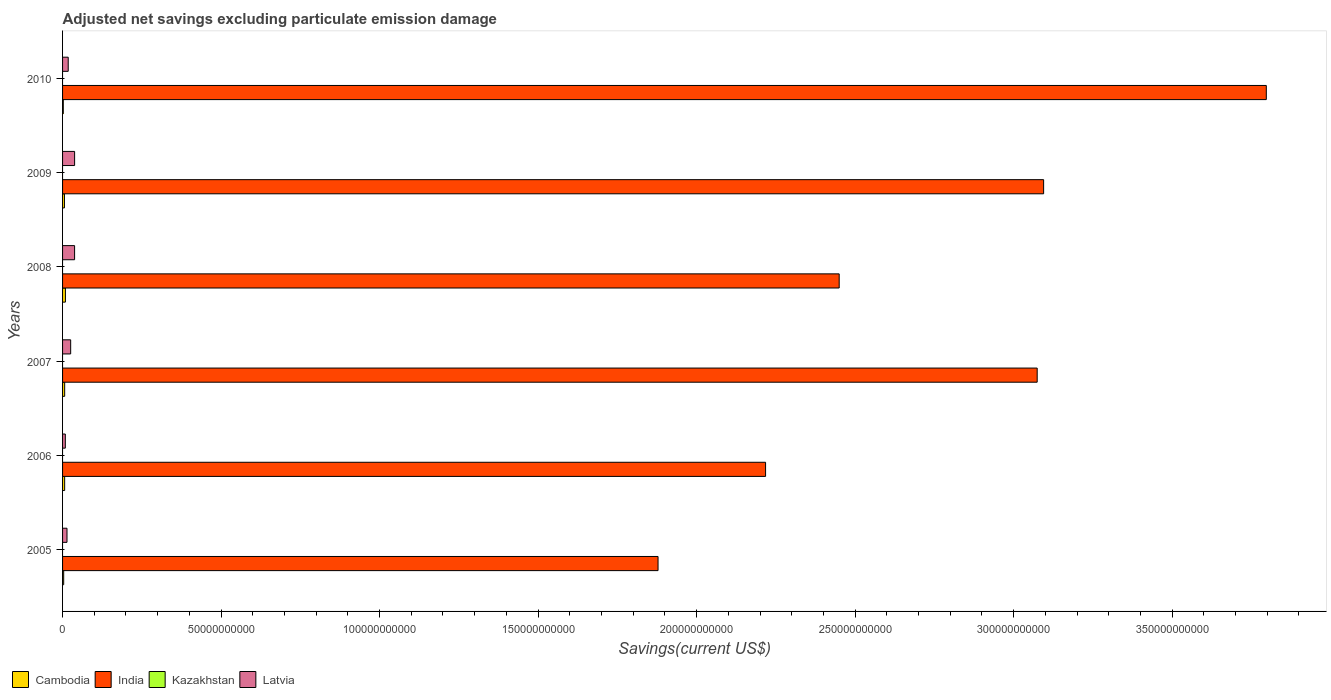How many different coloured bars are there?
Keep it short and to the point. 3. Are the number of bars per tick equal to the number of legend labels?
Keep it short and to the point. No. Are the number of bars on each tick of the Y-axis equal?
Offer a very short reply. Yes. How many bars are there on the 1st tick from the bottom?
Give a very brief answer. 3. What is the label of the 1st group of bars from the top?
Provide a succinct answer. 2010. What is the adjusted net savings in Cambodia in 2007?
Provide a succinct answer. 6.62e+08. Across all years, what is the maximum adjusted net savings in India?
Your answer should be very brief. 3.80e+11. Across all years, what is the minimum adjusted net savings in Cambodia?
Provide a short and direct response. 2.31e+08. In which year was the adjusted net savings in Latvia maximum?
Offer a very short reply. 2009. What is the total adjusted net savings in Cambodia in the graph?
Offer a very short reply. 3.40e+09. What is the difference between the adjusted net savings in Cambodia in 2008 and that in 2009?
Ensure brevity in your answer.  3.04e+08. What is the difference between the adjusted net savings in India in 2010 and the adjusted net savings in Latvia in 2008?
Ensure brevity in your answer.  3.76e+11. What is the average adjusted net savings in Kazakhstan per year?
Ensure brevity in your answer.  0. In the year 2006, what is the difference between the adjusted net savings in India and adjusted net savings in Cambodia?
Your answer should be compact. 2.21e+11. In how many years, is the adjusted net savings in India greater than 40000000000 US$?
Your answer should be compact. 6. What is the ratio of the adjusted net savings in India in 2005 to that in 2010?
Keep it short and to the point. 0.49. Is the difference between the adjusted net savings in India in 2008 and 2010 greater than the difference between the adjusted net savings in Cambodia in 2008 and 2010?
Your response must be concise. No. What is the difference between the highest and the second highest adjusted net savings in Cambodia?
Provide a short and direct response. 2.39e+08. What is the difference between the highest and the lowest adjusted net savings in Latvia?
Give a very brief answer. 2.93e+09. Is it the case that in every year, the sum of the adjusted net savings in Latvia and adjusted net savings in India is greater than the adjusted net savings in Kazakhstan?
Give a very brief answer. Yes. How many bars are there?
Offer a terse response. 18. How many years are there in the graph?
Ensure brevity in your answer.  6. Where does the legend appear in the graph?
Offer a terse response. Bottom left. What is the title of the graph?
Make the answer very short. Adjusted net savings excluding particulate emission damage. Does "Peru" appear as one of the legend labels in the graph?
Offer a terse response. No. What is the label or title of the X-axis?
Your answer should be very brief. Savings(current US$). What is the label or title of the Y-axis?
Your answer should be compact. Years. What is the Savings(current US$) of Cambodia in 2005?
Your answer should be very brief. 3.53e+08. What is the Savings(current US$) in India in 2005?
Your answer should be very brief. 1.88e+11. What is the Savings(current US$) in Kazakhstan in 2005?
Offer a terse response. 0. What is the Savings(current US$) in Latvia in 2005?
Keep it short and to the point. 1.40e+09. What is the Savings(current US$) of Cambodia in 2006?
Offer a very short reply. 6.58e+08. What is the Savings(current US$) of India in 2006?
Your response must be concise. 2.22e+11. What is the Savings(current US$) in Kazakhstan in 2006?
Provide a succinct answer. 0. What is the Savings(current US$) in Latvia in 2006?
Your answer should be compact. 8.71e+08. What is the Savings(current US$) of Cambodia in 2007?
Your answer should be compact. 6.62e+08. What is the Savings(current US$) in India in 2007?
Keep it short and to the point. 3.07e+11. What is the Savings(current US$) of Latvia in 2007?
Keep it short and to the point. 2.56e+09. What is the Savings(current US$) in Cambodia in 2008?
Your answer should be very brief. 9.01e+08. What is the Savings(current US$) in India in 2008?
Offer a terse response. 2.45e+11. What is the Savings(current US$) in Latvia in 2008?
Provide a short and direct response. 3.79e+09. What is the Savings(current US$) in Cambodia in 2009?
Your response must be concise. 5.97e+08. What is the Savings(current US$) in India in 2009?
Provide a short and direct response. 3.09e+11. What is the Savings(current US$) of Latvia in 2009?
Your answer should be very brief. 3.80e+09. What is the Savings(current US$) in Cambodia in 2010?
Provide a succinct answer. 2.31e+08. What is the Savings(current US$) of India in 2010?
Ensure brevity in your answer.  3.80e+11. What is the Savings(current US$) of Kazakhstan in 2010?
Your answer should be compact. 0. What is the Savings(current US$) in Latvia in 2010?
Your answer should be compact. 1.78e+09. Across all years, what is the maximum Savings(current US$) in Cambodia?
Offer a terse response. 9.01e+08. Across all years, what is the maximum Savings(current US$) in India?
Your response must be concise. 3.80e+11. Across all years, what is the maximum Savings(current US$) of Latvia?
Keep it short and to the point. 3.80e+09. Across all years, what is the minimum Savings(current US$) in Cambodia?
Offer a very short reply. 2.31e+08. Across all years, what is the minimum Savings(current US$) of India?
Keep it short and to the point. 1.88e+11. Across all years, what is the minimum Savings(current US$) in Latvia?
Provide a short and direct response. 8.71e+08. What is the total Savings(current US$) in Cambodia in the graph?
Keep it short and to the point. 3.40e+09. What is the total Savings(current US$) in India in the graph?
Your response must be concise. 1.65e+12. What is the total Savings(current US$) in Kazakhstan in the graph?
Your answer should be very brief. 0. What is the total Savings(current US$) in Latvia in the graph?
Provide a succinct answer. 1.42e+1. What is the difference between the Savings(current US$) in Cambodia in 2005 and that in 2006?
Your answer should be compact. -3.05e+08. What is the difference between the Savings(current US$) of India in 2005 and that in 2006?
Provide a short and direct response. -3.39e+1. What is the difference between the Savings(current US$) of Latvia in 2005 and that in 2006?
Your answer should be compact. 5.25e+08. What is the difference between the Savings(current US$) of Cambodia in 2005 and that in 2007?
Make the answer very short. -3.09e+08. What is the difference between the Savings(current US$) in India in 2005 and that in 2007?
Give a very brief answer. -1.20e+11. What is the difference between the Savings(current US$) of Latvia in 2005 and that in 2007?
Provide a short and direct response. -1.16e+09. What is the difference between the Savings(current US$) in Cambodia in 2005 and that in 2008?
Give a very brief answer. -5.48e+08. What is the difference between the Savings(current US$) in India in 2005 and that in 2008?
Ensure brevity in your answer.  -5.71e+1. What is the difference between the Savings(current US$) of Latvia in 2005 and that in 2008?
Offer a terse response. -2.40e+09. What is the difference between the Savings(current US$) of Cambodia in 2005 and that in 2009?
Keep it short and to the point. -2.44e+08. What is the difference between the Savings(current US$) of India in 2005 and that in 2009?
Offer a terse response. -1.22e+11. What is the difference between the Savings(current US$) of Latvia in 2005 and that in 2009?
Make the answer very short. -2.40e+09. What is the difference between the Savings(current US$) of Cambodia in 2005 and that in 2010?
Your answer should be very brief. 1.22e+08. What is the difference between the Savings(current US$) in India in 2005 and that in 2010?
Keep it short and to the point. -1.92e+11. What is the difference between the Savings(current US$) in Latvia in 2005 and that in 2010?
Offer a terse response. -3.87e+08. What is the difference between the Savings(current US$) in Cambodia in 2006 and that in 2007?
Keep it short and to the point. -3.74e+06. What is the difference between the Savings(current US$) of India in 2006 and that in 2007?
Give a very brief answer. -8.57e+1. What is the difference between the Savings(current US$) of Latvia in 2006 and that in 2007?
Provide a short and direct response. -1.68e+09. What is the difference between the Savings(current US$) of Cambodia in 2006 and that in 2008?
Your answer should be compact. -2.43e+08. What is the difference between the Savings(current US$) in India in 2006 and that in 2008?
Provide a short and direct response. -2.32e+1. What is the difference between the Savings(current US$) in Latvia in 2006 and that in 2008?
Offer a terse response. -2.92e+09. What is the difference between the Savings(current US$) of Cambodia in 2006 and that in 2009?
Give a very brief answer. 6.14e+07. What is the difference between the Savings(current US$) in India in 2006 and that in 2009?
Provide a succinct answer. -8.77e+1. What is the difference between the Savings(current US$) of Latvia in 2006 and that in 2009?
Make the answer very short. -2.93e+09. What is the difference between the Savings(current US$) in Cambodia in 2006 and that in 2010?
Provide a succinct answer. 4.27e+08. What is the difference between the Savings(current US$) in India in 2006 and that in 2010?
Keep it short and to the point. -1.58e+11. What is the difference between the Savings(current US$) of Latvia in 2006 and that in 2010?
Provide a succinct answer. -9.13e+08. What is the difference between the Savings(current US$) in Cambodia in 2007 and that in 2008?
Offer a terse response. -2.39e+08. What is the difference between the Savings(current US$) of India in 2007 and that in 2008?
Your answer should be very brief. 6.25e+1. What is the difference between the Savings(current US$) in Latvia in 2007 and that in 2008?
Provide a succinct answer. -1.24e+09. What is the difference between the Savings(current US$) in Cambodia in 2007 and that in 2009?
Your answer should be very brief. 6.52e+07. What is the difference between the Savings(current US$) in India in 2007 and that in 2009?
Give a very brief answer. -2.03e+09. What is the difference between the Savings(current US$) in Latvia in 2007 and that in 2009?
Offer a terse response. -1.24e+09. What is the difference between the Savings(current US$) in Cambodia in 2007 and that in 2010?
Keep it short and to the point. 4.31e+08. What is the difference between the Savings(current US$) in India in 2007 and that in 2010?
Ensure brevity in your answer.  -7.23e+1. What is the difference between the Savings(current US$) in Latvia in 2007 and that in 2010?
Your answer should be very brief. 7.72e+08. What is the difference between the Savings(current US$) in Cambodia in 2008 and that in 2009?
Offer a terse response. 3.04e+08. What is the difference between the Savings(current US$) of India in 2008 and that in 2009?
Provide a succinct answer. -6.45e+1. What is the difference between the Savings(current US$) in Latvia in 2008 and that in 2009?
Your answer should be compact. -3.63e+06. What is the difference between the Savings(current US$) in Cambodia in 2008 and that in 2010?
Keep it short and to the point. 6.70e+08. What is the difference between the Savings(current US$) of India in 2008 and that in 2010?
Provide a succinct answer. -1.35e+11. What is the difference between the Savings(current US$) of Latvia in 2008 and that in 2010?
Make the answer very short. 2.01e+09. What is the difference between the Savings(current US$) of Cambodia in 2009 and that in 2010?
Your answer should be compact. 3.66e+08. What is the difference between the Savings(current US$) in India in 2009 and that in 2010?
Your answer should be very brief. -7.02e+1. What is the difference between the Savings(current US$) of Latvia in 2009 and that in 2010?
Make the answer very short. 2.01e+09. What is the difference between the Savings(current US$) in Cambodia in 2005 and the Savings(current US$) in India in 2006?
Your answer should be very brief. -2.21e+11. What is the difference between the Savings(current US$) in Cambodia in 2005 and the Savings(current US$) in Latvia in 2006?
Provide a short and direct response. -5.18e+08. What is the difference between the Savings(current US$) of India in 2005 and the Savings(current US$) of Latvia in 2006?
Your response must be concise. 1.87e+11. What is the difference between the Savings(current US$) of Cambodia in 2005 and the Savings(current US$) of India in 2007?
Your response must be concise. -3.07e+11. What is the difference between the Savings(current US$) of Cambodia in 2005 and the Savings(current US$) of Latvia in 2007?
Provide a succinct answer. -2.20e+09. What is the difference between the Savings(current US$) of India in 2005 and the Savings(current US$) of Latvia in 2007?
Give a very brief answer. 1.85e+11. What is the difference between the Savings(current US$) in Cambodia in 2005 and the Savings(current US$) in India in 2008?
Your answer should be compact. -2.45e+11. What is the difference between the Savings(current US$) in Cambodia in 2005 and the Savings(current US$) in Latvia in 2008?
Make the answer very short. -3.44e+09. What is the difference between the Savings(current US$) of India in 2005 and the Savings(current US$) of Latvia in 2008?
Make the answer very short. 1.84e+11. What is the difference between the Savings(current US$) of Cambodia in 2005 and the Savings(current US$) of India in 2009?
Offer a terse response. -3.09e+11. What is the difference between the Savings(current US$) of Cambodia in 2005 and the Savings(current US$) of Latvia in 2009?
Make the answer very short. -3.44e+09. What is the difference between the Savings(current US$) of India in 2005 and the Savings(current US$) of Latvia in 2009?
Make the answer very short. 1.84e+11. What is the difference between the Savings(current US$) of Cambodia in 2005 and the Savings(current US$) of India in 2010?
Offer a very short reply. -3.79e+11. What is the difference between the Savings(current US$) in Cambodia in 2005 and the Savings(current US$) in Latvia in 2010?
Make the answer very short. -1.43e+09. What is the difference between the Savings(current US$) of India in 2005 and the Savings(current US$) of Latvia in 2010?
Provide a succinct answer. 1.86e+11. What is the difference between the Savings(current US$) of Cambodia in 2006 and the Savings(current US$) of India in 2007?
Ensure brevity in your answer.  -3.07e+11. What is the difference between the Savings(current US$) in Cambodia in 2006 and the Savings(current US$) in Latvia in 2007?
Keep it short and to the point. -1.90e+09. What is the difference between the Savings(current US$) in India in 2006 and the Savings(current US$) in Latvia in 2007?
Offer a terse response. 2.19e+11. What is the difference between the Savings(current US$) of Cambodia in 2006 and the Savings(current US$) of India in 2008?
Keep it short and to the point. -2.44e+11. What is the difference between the Savings(current US$) of Cambodia in 2006 and the Savings(current US$) of Latvia in 2008?
Offer a terse response. -3.14e+09. What is the difference between the Savings(current US$) of India in 2006 and the Savings(current US$) of Latvia in 2008?
Make the answer very short. 2.18e+11. What is the difference between the Savings(current US$) of Cambodia in 2006 and the Savings(current US$) of India in 2009?
Give a very brief answer. -3.09e+11. What is the difference between the Savings(current US$) of Cambodia in 2006 and the Savings(current US$) of Latvia in 2009?
Provide a succinct answer. -3.14e+09. What is the difference between the Savings(current US$) of India in 2006 and the Savings(current US$) of Latvia in 2009?
Keep it short and to the point. 2.18e+11. What is the difference between the Savings(current US$) in Cambodia in 2006 and the Savings(current US$) in India in 2010?
Keep it short and to the point. -3.79e+11. What is the difference between the Savings(current US$) in Cambodia in 2006 and the Savings(current US$) in Latvia in 2010?
Keep it short and to the point. -1.13e+09. What is the difference between the Savings(current US$) in India in 2006 and the Savings(current US$) in Latvia in 2010?
Give a very brief answer. 2.20e+11. What is the difference between the Savings(current US$) in Cambodia in 2007 and the Savings(current US$) in India in 2008?
Your answer should be compact. -2.44e+11. What is the difference between the Savings(current US$) in Cambodia in 2007 and the Savings(current US$) in Latvia in 2008?
Your answer should be very brief. -3.13e+09. What is the difference between the Savings(current US$) of India in 2007 and the Savings(current US$) of Latvia in 2008?
Ensure brevity in your answer.  3.04e+11. What is the difference between the Savings(current US$) in Cambodia in 2007 and the Savings(current US$) in India in 2009?
Provide a succinct answer. -3.09e+11. What is the difference between the Savings(current US$) of Cambodia in 2007 and the Savings(current US$) of Latvia in 2009?
Provide a short and direct response. -3.14e+09. What is the difference between the Savings(current US$) of India in 2007 and the Savings(current US$) of Latvia in 2009?
Make the answer very short. 3.04e+11. What is the difference between the Savings(current US$) of Cambodia in 2007 and the Savings(current US$) of India in 2010?
Your answer should be very brief. -3.79e+11. What is the difference between the Savings(current US$) in Cambodia in 2007 and the Savings(current US$) in Latvia in 2010?
Provide a succinct answer. -1.12e+09. What is the difference between the Savings(current US$) of India in 2007 and the Savings(current US$) of Latvia in 2010?
Offer a very short reply. 3.06e+11. What is the difference between the Savings(current US$) of Cambodia in 2008 and the Savings(current US$) of India in 2009?
Make the answer very short. -3.09e+11. What is the difference between the Savings(current US$) in Cambodia in 2008 and the Savings(current US$) in Latvia in 2009?
Provide a short and direct response. -2.90e+09. What is the difference between the Savings(current US$) in India in 2008 and the Savings(current US$) in Latvia in 2009?
Keep it short and to the point. 2.41e+11. What is the difference between the Savings(current US$) of Cambodia in 2008 and the Savings(current US$) of India in 2010?
Keep it short and to the point. -3.79e+11. What is the difference between the Savings(current US$) of Cambodia in 2008 and the Savings(current US$) of Latvia in 2010?
Provide a short and direct response. -8.83e+08. What is the difference between the Savings(current US$) of India in 2008 and the Savings(current US$) of Latvia in 2010?
Ensure brevity in your answer.  2.43e+11. What is the difference between the Savings(current US$) in Cambodia in 2009 and the Savings(current US$) in India in 2010?
Provide a succinct answer. -3.79e+11. What is the difference between the Savings(current US$) in Cambodia in 2009 and the Savings(current US$) in Latvia in 2010?
Ensure brevity in your answer.  -1.19e+09. What is the difference between the Savings(current US$) of India in 2009 and the Savings(current US$) of Latvia in 2010?
Keep it short and to the point. 3.08e+11. What is the average Savings(current US$) in Cambodia per year?
Your answer should be very brief. 5.67e+08. What is the average Savings(current US$) in India per year?
Your answer should be compact. 2.75e+11. What is the average Savings(current US$) in Kazakhstan per year?
Your answer should be compact. 0. What is the average Savings(current US$) in Latvia per year?
Provide a succinct answer. 2.37e+09. In the year 2005, what is the difference between the Savings(current US$) in Cambodia and Savings(current US$) in India?
Make the answer very short. -1.87e+11. In the year 2005, what is the difference between the Savings(current US$) of Cambodia and Savings(current US$) of Latvia?
Ensure brevity in your answer.  -1.04e+09. In the year 2005, what is the difference between the Savings(current US$) of India and Savings(current US$) of Latvia?
Your response must be concise. 1.86e+11. In the year 2006, what is the difference between the Savings(current US$) of Cambodia and Savings(current US$) of India?
Your answer should be compact. -2.21e+11. In the year 2006, what is the difference between the Savings(current US$) in Cambodia and Savings(current US$) in Latvia?
Your response must be concise. -2.13e+08. In the year 2006, what is the difference between the Savings(current US$) in India and Savings(current US$) in Latvia?
Provide a succinct answer. 2.21e+11. In the year 2007, what is the difference between the Savings(current US$) in Cambodia and Savings(current US$) in India?
Provide a short and direct response. -3.07e+11. In the year 2007, what is the difference between the Savings(current US$) of Cambodia and Savings(current US$) of Latvia?
Your answer should be very brief. -1.89e+09. In the year 2007, what is the difference between the Savings(current US$) in India and Savings(current US$) in Latvia?
Your answer should be compact. 3.05e+11. In the year 2008, what is the difference between the Savings(current US$) in Cambodia and Savings(current US$) in India?
Ensure brevity in your answer.  -2.44e+11. In the year 2008, what is the difference between the Savings(current US$) of Cambodia and Savings(current US$) of Latvia?
Your answer should be compact. -2.89e+09. In the year 2008, what is the difference between the Savings(current US$) of India and Savings(current US$) of Latvia?
Provide a short and direct response. 2.41e+11. In the year 2009, what is the difference between the Savings(current US$) in Cambodia and Savings(current US$) in India?
Provide a succinct answer. -3.09e+11. In the year 2009, what is the difference between the Savings(current US$) in Cambodia and Savings(current US$) in Latvia?
Offer a terse response. -3.20e+09. In the year 2009, what is the difference between the Savings(current US$) of India and Savings(current US$) of Latvia?
Make the answer very short. 3.06e+11. In the year 2010, what is the difference between the Savings(current US$) in Cambodia and Savings(current US$) in India?
Ensure brevity in your answer.  -3.79e+11. In the year 2010, what is the difference between the Savings(current US$) in Cambodia and Savings(current US$) in Latvia?
Provide a succinct answer. -1.55e+09. In the year 2010, what is the difference between the Savings(current US$) of India and Savings(current US$) of Latvia?
Your response must be concise. 3.78e+11. What is the ratio of the Savings(current US$) of Cambodia in 2005 to that in 2006?
Offer a terse response. 0.54. What is the ratio of the Savings(current US$) of India in 2005 to that in 2006?
Offer a terse response. 0.85. What is the ratio of the Savings(current US$) in Latvia in 2005 to that in 2006?
Offer a terse response. 1.6. What is the ratio of the Savings(current US$) in Cambodia in 2005 to that in 2007?
Keep it short and to the point. 0.53. What is the ratio of the Savings(current US$) in India in 2005 to that in 2007?
Provide a short and direct response. 0.61. What is the ratio of the Savings(current US$) in Latvia in 2005 to that in 2007?
Make the answer very short. 0.55. What is the ratio of the Savings(current US$) of Cambodia in 2005 to that in 2008?
Provide a short and direct response. 0.39. What is the ratio of the Savings(current US$) of India in 2005 to that in 2008?
Provide a short and direct response. 0.77. What is the ratio of the Savings(current US$) of Latvia in 2005 to that in 2008?
Give a very brief answer. 0.37. What is the ratio of the Savings(current US$) in Cambodia in 2005 to that in 2009?
Keep it short and to the point. 0.59. What is the ratio of the Savings(current US$) of India in 2005 to that in 2009?
Offer a very short reply. 0.61. What is the ratio of the Savings(current US$) in Latvia in 2005 to that in 2009?
Your answer should be very brief. 0.37. What is the ratio of the Savings(current US$) of Cambodia in 2005 to that in 2010?
Provide a short and direct response. 1.53. What is the ratio of the Savings(current US$) in India in 2005 to that in 2010?
Offer a terse response. 0.49. What is the ratio of the Savings(current US$) in Latvia in 2005 to that in 2010?
Your response must be concise. 0.78. What is the ratio of the Savings(current US$) of Cambodia in 2006 to that in 2007?
Offer a very short reply. 0.99. What is the ratio of the Savings(current US$) in India in 2006 to that in 2007?
Give a very brief answer. 0.72. What is the ratio of the Savings(current US$) of Latvia in 2006 to that in 2007?
Offer a very short reply. 0.34. What is the ratio of the Savings(current US$) of Cambodia in 2006 to that in 2008?
Provide a succinct answer. 0.73. What is the ratio of the Savings(current US$) of India in 2006 to that in 2008?
Make the answer very short. 0.91. What is the ratio of the Savings(current US$) in Latvia in 2006 to that in 2008?
Provide a short and direct response. 0.23. What is the ratio of the Savings(current US$) of Cambodia in 2006 to that in 2009?
Provide a succinct answer. 1.1. What is the ratio of the Savings(current US$) in India in 2006 to that in 2009?
Keep it short and to the point. 0.72. What is the ratio of the Savings(current US$) of Latvia in 2006 to that in 2009?
Make the answer very short. 0.23. What is the ratio of the Savings(current US$) in Cambodia in 2006 to that in 2010?
Ensure brevity in your answer.  2.85. What is the ratio of the Savings(current US$) in India in 2006 to that in 2010?
Your answer should be very brief. 0.58. What is the ratio of the Savings(current US$) in Latvia in 2006 to that in 2010?
Ensure brevity in your answer.  0.49. What is the ratio of the Savings(current US$) in Cambodia in 2007 to that in 2008?
Ensure brevity in your answer.  0.73. What is the ratio of the Savings(current US$) of India in 2007 to that in 2008?
Your answer should be compact. 1.25. What is the ratio of the Savings(current US$) of Latvia in 2007 to that in 2008?
Provide a short and direct response. 0.67. What is the ratio of the Savings(current US$) of Cambodia in 2007 to that in 2009?
Your response must be concise. 1.11. What is the ratio of the Savings(current US$) of Latvia in 2007 to that in 2009?
Offer a very short reply. 0.67. What is the ratio of the Savings(current US$) of Cambodia in 2007 to that in 2010?
Offer a terse response. 2.86. What is the ratio of the Savings(current US$) of India in 2007 to that in 2010?
Your answer should be compact. 0.81. What is the ratio of the Savings(current US$) of Latvia in 2007 to that in 2010?
Your answer should be very brief. 1.43. What is the ratio of the Savings(current US$) in Cambodia in 2008 to that in 2009?
Offer a very short reply. 1.51. What is the ratio of the Savings(current US$) in India in 2008 to that in 2009?
Make the answer very short. 0.79. What is the ratio of the Savings(current US$) of Latvia in 2008 to that in 2009?
Keep it short and to the point. 1. What is the ratio of the Savings(current US$) of Cambodia in 2008 to that in 2010?
Give a very brief answer. 3.9. What is the ratio of the Savings(current US$) in India in 2008 to that in 2010?
Offer a very short reply. 0.65. What is the ratio of the Savings(current US$) in Latvia in 2008 to that in 2010?
Offer a very short reply. 2.13. What is the ratio of the Savings(current US$) in Cambodia in 2009 to that in 2010?
Provide a succinct answer. 2.58. What is the ratio of the Savings(current US$) of India in 2009 to that in 2010?
Provide a short and direct response. 0.81. What is the ratio of the Savings(current US$) in Latvia in 2009 to that in 2010?
Your answer should be very brief. 2.13. What is the difference between the highest and the second highest Savings(current US$) of Cambodia?
Ensure brevity in your answer.  2.39e+08. What is the difference between the highest and the second highest Savings(current US$) of India?
Make the answer very short. 7.02e+1. What is the difference between the highest and the second highest Savings(current US$) in Latvia?
Provide a succinct answer. 3.63e+06. What is the difference between the highest and the lowest Savings(current US$) of Cambodia?
Make the answer very short. 6.70e+08. What is the difference between the highest and the lowest Savings(current US$) of India?
Provide a short and direct response. 1.92e+11. What is the difference between the highest and the lowest Savings(current US$) in Latvia?
Provide a short and direct response. 2.93e+09. 